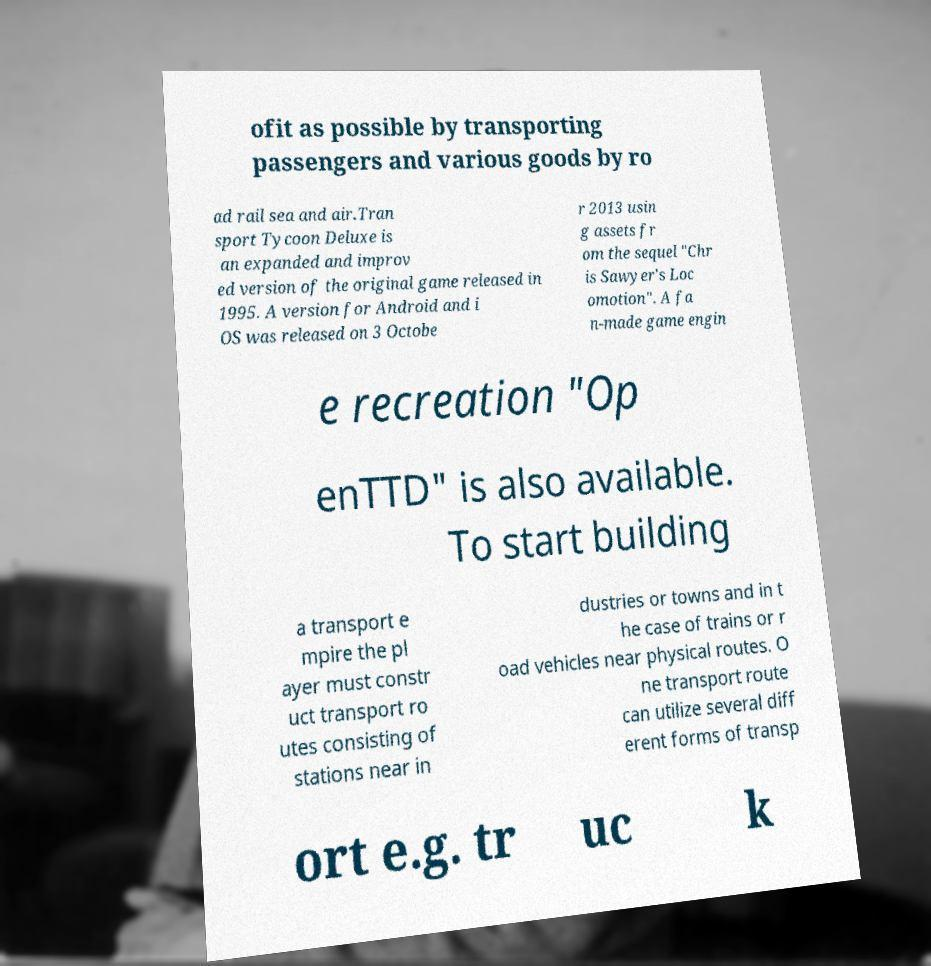Could you assist in decoding the text presented in this image and type it out clearly? ofit as possible by transporting passengers and various goods by ro ad rail sea and air.Tran sport Tycoon Deluxe is an expanded and improv ed version of the original game released in 1995. A version for Android and i OS was released on 3 Octobe r 2013 usin g assets fr om the sequel "Chr is Sawyer's Loc omotion". A fa n-made game engin e recreation "Op enTTD" is also available. To start building a transport e mpire the pl ayer must constr uct transport ro utes consisting of stations near in dustries or towns and in t he case of trains or r oad vehicles near physical routes. O ne transport route can utilize several diff erent forms of transp ort e.g. tr uc k 